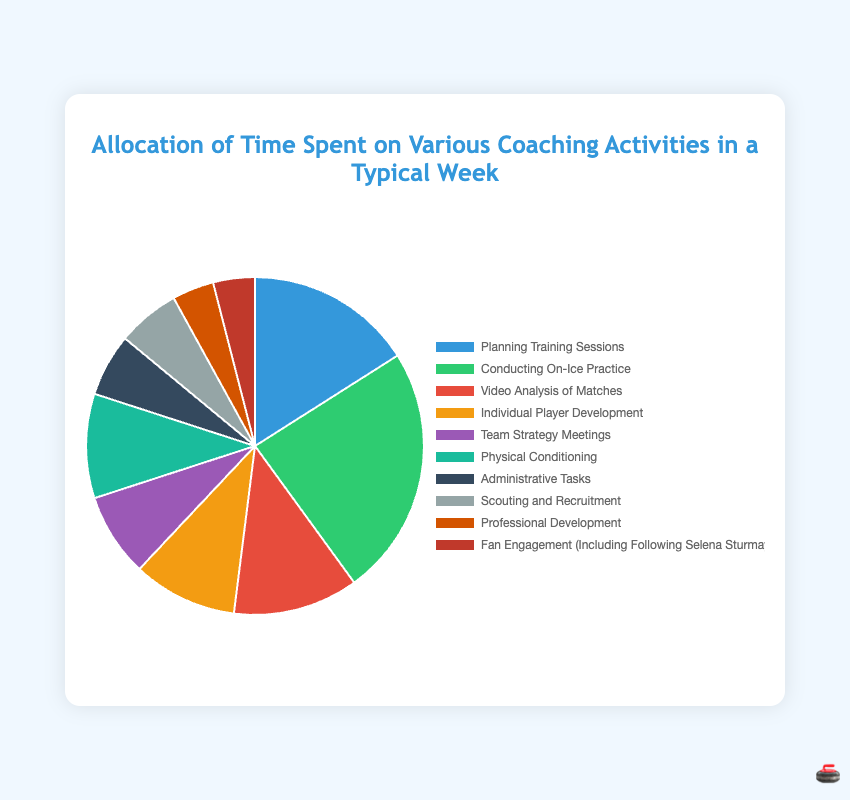What is the total time spent on Physical Conditioning and Individual Player Development? The time spent on Physical Conditioning is 5 hours and on Individual Player Development is 5 hours. Adding these together: 5 + 5 = 10 hours.
Answer: 10 hours Which activity takes more time: Team Strategy Meetings or Administrative Tasks? Team Strategy Meetings take 4 hours, while Administrative Tasks take 3 hours. Comparing the two: 4 hours is more than 3 hours.
Answer: Team Strategy Meetings What percentage of the total time is spent on Fan Engagement? Fan Engagement takes 2 hours. The total time spent on all activities is 50 hours. The percentage is calculated as follows: (2/50) * 100 = 4%.
Answer: 4% Which activity takes the least amount of time? The activities with the smallest time allocation are Professional Development and Fan Engagement, each taking 2 hours.
Answer: Professional Development, Fan Engagement What is the difference in time spent between Conducting On-Ice Practice and Planning Training Sessions? Time spent on Conducting On-Ice Practice is 12 hours and on Planning Training Sessions is 8 hours. The difference is 12 - 8 = 4 hours.
Answer: 4 hours What is the total time spent on Conducting On-Ice Practice, Video Analysis of Matches, and Scouting and Recruitment? Conducting On-Ice Practice takes 12 hours, Video Analysis of Matches takes 6 hours, and Scouting and Recruitment takes 3 hours. Adding these together: 12 + 6 + 3 = 21 hours.
Answer: 21 hours How much more time is spent on Conducting On-Ice Practice compared to Scouting and Recruitment? Time spent on Conducting On-Ice Practice is 12 hours, and on Scouting and Recruitment is 3 hours. The difference is 12 - 3 = 9 hours.
Answer: 9 hours What color represents Video Analysis of Matches? The color associated with Video Analysis of Matches is red.
Answer: red 